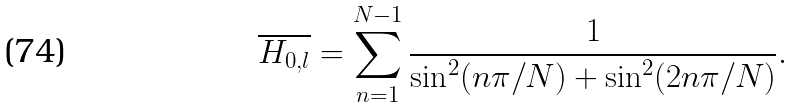<formula> <loc_0><loc_0><loc_500><loc_500>\overline { H _ { 0 , l } } = \sum _ { n = 1 } ^ { N - 1 } \frac { 1 } { \sin ^ { 2 } ( n \pi / N ) + \sin ^ { 2 } ( 2 n \pi / N ) } .</formula> 